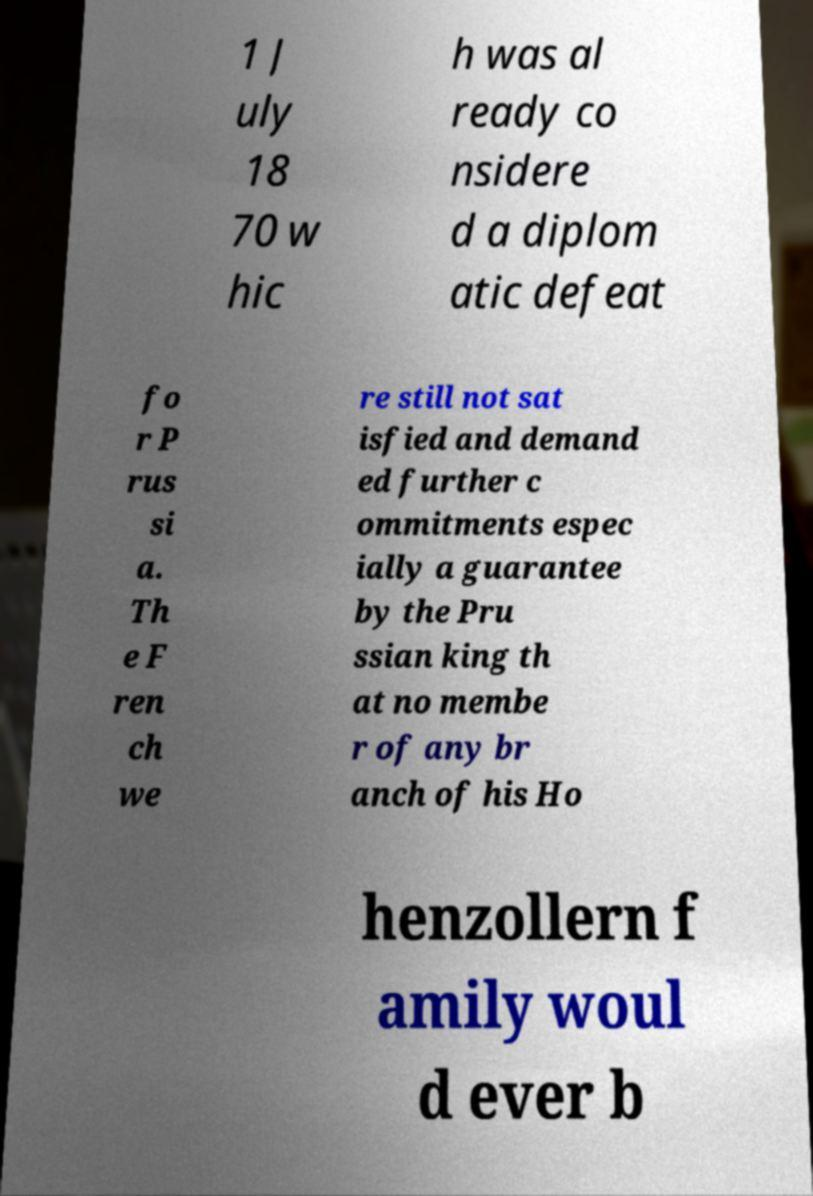Could you extract and type out the text from this image? 1 J uly 18 70 w hic h was al ready co nsidere d a diplom atic defeat fo r P rus si a. Th e F ren ch we re still not sat isfied and demand ed further c ommitments espec ially a guarantee by the Pru ssian king th at no membe r of any br anch of his Ho henzollern f amily woul d ever b 